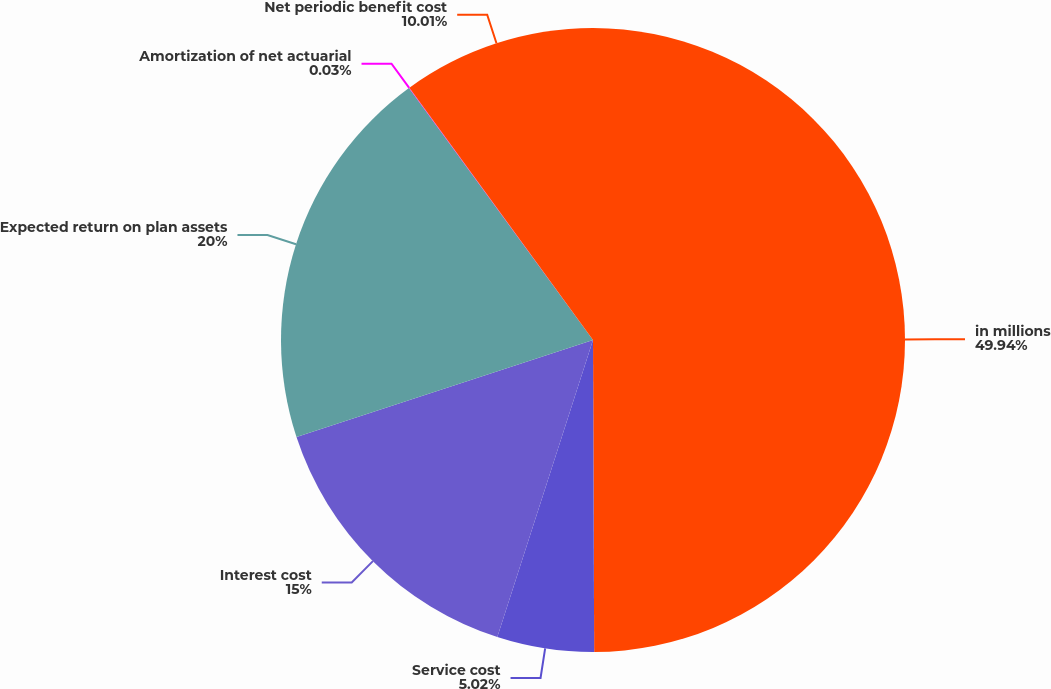<chart> <loc_0><loc_0><loc_500><loc_500><pie_chart><fcel>in millions<fcel>Service cost<fcel>Interest cost<fcel>Expected return on plan assets<fcel>Amortization of net actuarial<fcel>Net periodic benefit cost<nl><fcel>49.93%<fcel>5.02%<fcel>15.0%<fcel>19.99%<fcel>0.03%<fcel>10.01%<nl></chart> 